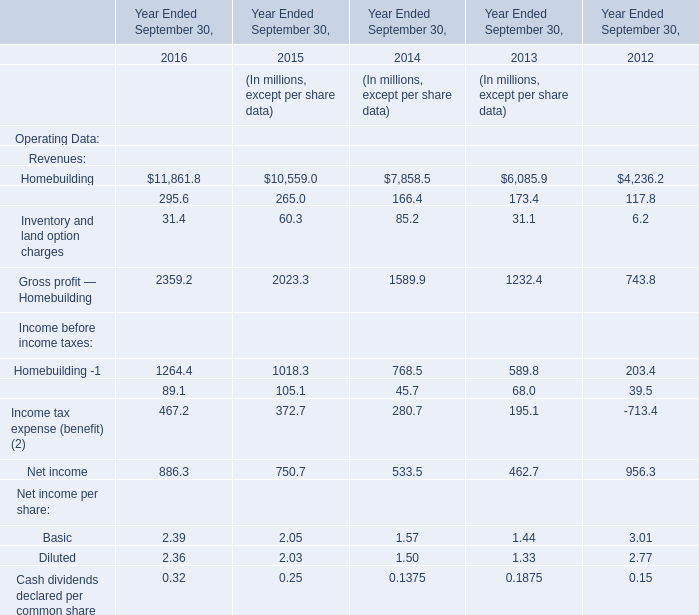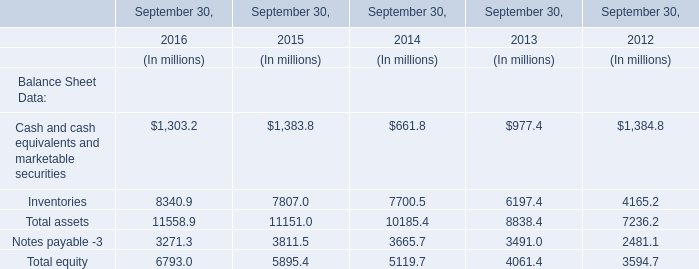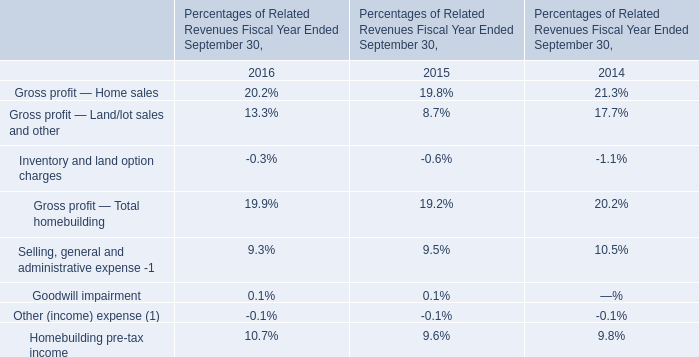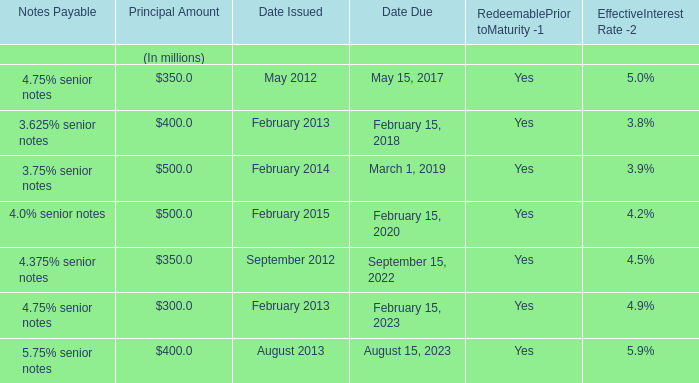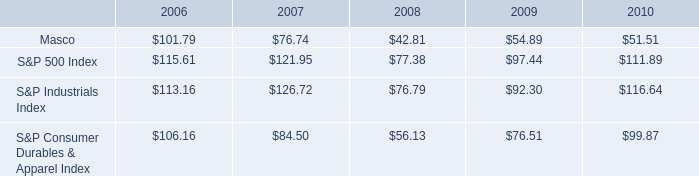Which year is Inventory and land option charges the least? 
Answer: 2012. 